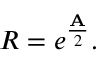<formula> <loc_0><loc_0><loc_500><loc_500>R = e ^ { \frac { A } { 2 } } .</formula> 